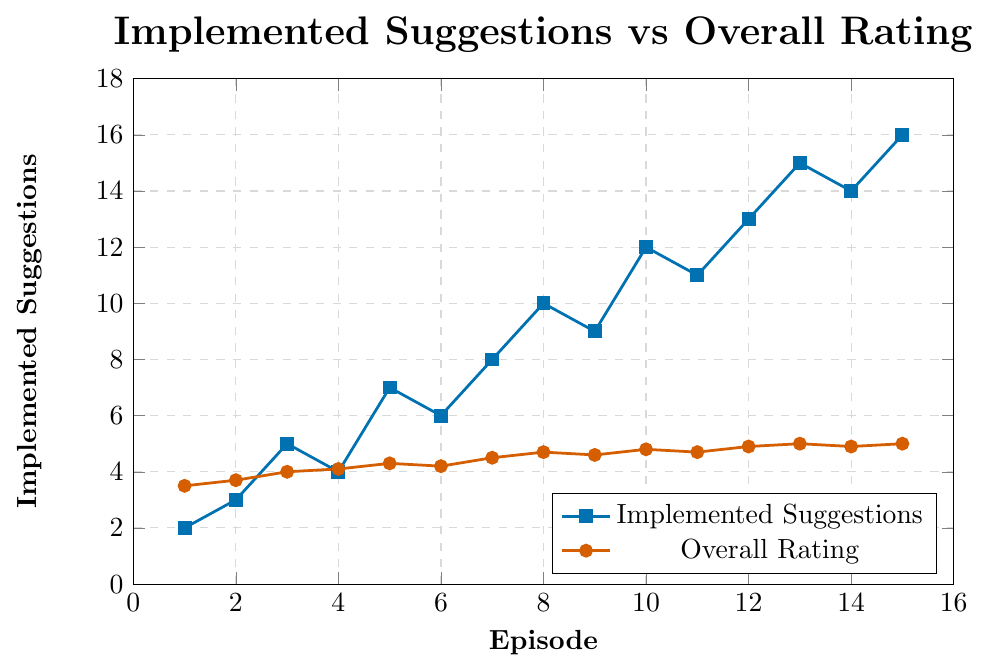What is the overall rating for Episode 10? Locate Episode 10 on the horizontal axis and find the corresponding point in red. The overall rating for Episode 10 is 4.8.
Answer: 4.8 How many suggestions were implemented by Episode 5? Locate Episode 5 on the horizontal axis and find the corresponding point in blue. The number of implemented suggestions by Episode 5 is 7.
Answer: 7 By how much did the overall rating increase from Episode 3 to Episode 4? Locate Episodes 3 and 4 on the horizontal axis and note their respective overall ratings from the red line (4.0 and 4.1). Subtract the two values: 4.1 - 4.0.
Answer: 0.1 Which episode had the highest number of implemented suggestions, and what was its overall rating? Find the episode with the highest blue point on the chart; this is Episode 15 with 16 implemented suggestions. The corresponding overall rating (red point) for Episode 15 is 5.0.
Answer: Episode 15; 5.0 What is the general trend in the relationship between implemented suggestions and overall rating? Observe both lines: as the number of implemented suggestions (blue line) increases, the overall rating (red line) tends to increase as well. This indicates a positive correlation between implemented suggestions and overall ratings.
Answer: Positive correlation Compare the number of implemented suggestions and the overall rating for Episodes 7 and 8. For Episode 7: 8 implemented suggestions and an overall rating of 4.5. For Episode 8: 10 implemented suggestions and an overall rating of 4.7. Both measures increase from Episode 7 to 8.
Answer: Episode 8 has more implemented suggestions and a higher rating Between which two consecutive episodes was the largest increase in implemented suggestions observed? Compare blue line points for each pair of consecutive episodes to find the largest difference. From Episode 4 to Episode 5, the change is greatest: 7 - 4 = 3.
Answer: Between Episodes 4 and 5 What was the overall rating when 13 suggestions were implemented, and during which episode did this occur? Locate the point where implemented suggestions equal 13 (blue line) at Episode 12; the corresponding red point shows an overall rating of 4.9.
Answer: 4.9; Episode 12 What episode corresponds to the first instance where the overall rating reached 5.0? Check red points along the horizontal axis and identify the first episode with a maximum rating of 5.0. This occurs at Episode 13.
Answer: Episode 13 If the average number of implemented suggestions from Episode 1 to Episode 5 is calculated, what is the result? Add the implemented suggestions from Episodes 1 to 5: 2 + 3 + 5 + 4 + 7 = 21. Then divide by 5 (the number of episodes): 21 / 5 = 4.2.
Answer: 4.2 